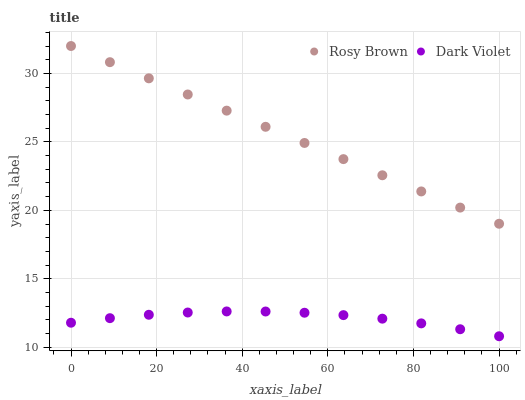Does Dark Violet have the minimum area under the curve?
Answer yes or no. Yes. Does Rosy Brown have the maximum area under the curve?
Answer yes or no. Yes. Does Dark Violet have the maximum area under the curve?
Answer yes or no. No. Is Rosy Brown the smoothest?
Answer yes or no. Yes. Is Dark Violet the roughest?
Answer yes or no. Yes. Is Dark Violet the smoothest?
Answer yes or no. No. Does Dark Violet have the lowest value?
Answer yes or no. Yes. Does Rosy Brown have the highest value?
Answer yes or no. Yes. Does Dark Violet have the highest value?
Answer yes or no. No. Is Dark Violet less than Rosy Brown?
Answer yes or no. Yes. Is Rosy Brown greater than Dark Violet?
Answer yes or no. Yes. Does Dark Violet intersect Rosy Brown?
Answer yes or no. No. 